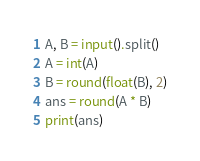<code> <loc_0><loc_0><loc_500><loc_500><_Python_>A, B = input().split()
A = int(A)
B = round(float(B), 2)
ans = round(A * B)
print(ans)</code> 